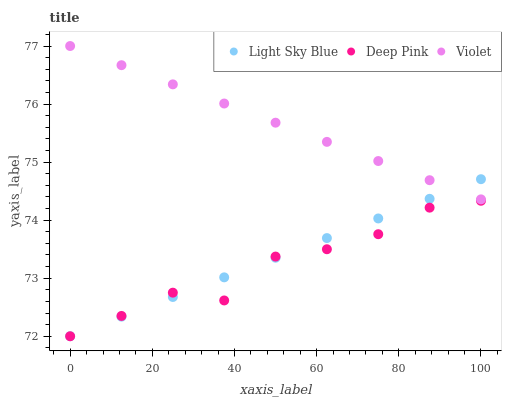Does Deep Pink have the minimum area under the curve?
Answer yes or no. Yes. Does Violet have the maximum area under the curve?
Answer yes or no. Yes. Does Violet have the minimum area under the curve?
Answer yes or no. No. Does Deep Pink have the maximum area under the curve?
Answer yes or no. No. Is Light Sky Blue the smoothest?
Answer yes or no. Yes. Is Deep Pink the roughest?
Answer yes or no. Yes. Is Deep Pink the smoothest?
Answer yes or no. No. Is Violet the roughest?
Answer yes or no. No. Does Light Sky Blue have the lowest value?
Answer yes or no. Yes. Does Violet have the lowest value?
Answer yes or no. No. Does Violet have the highest value?
Answer yes or no. Yes. Does Deep Pink have the highest value?
Answer yes or no. No. Is Deep Pink less than Violet?
Answer yes or no. Yes. Is Violet greater than Deep Pink?
Answer yes or no. Yes. Does Deep Pink intersect Light Sky Blue?
Answer yes or no. Yes. Is Deep Pink less than Light Sky Blue?
Answer yes or no. No. Is Deep Pink greater than Light Sky Blue?
Answer yes or no. No. Does Deep Pink intersect Violet?
Answer yes or no. No. 